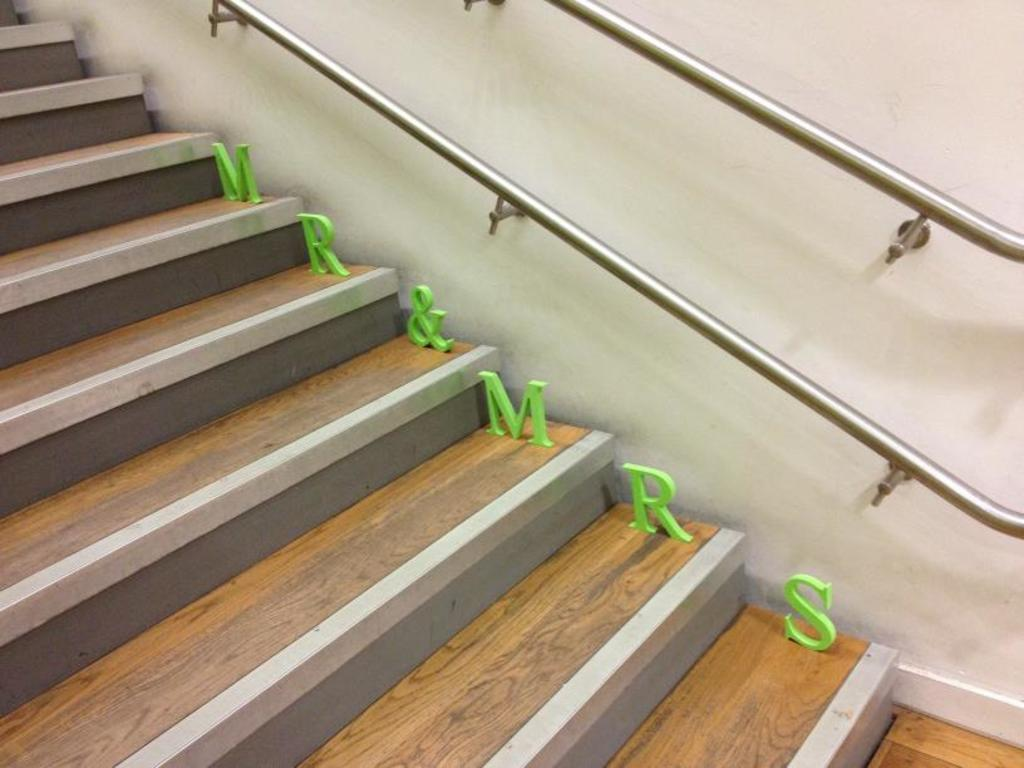What type of structure is present in the image? There is a staircase in the image. What can be seen on the staircase? Alphabets are visible in the image. What other objects are present in the image? There are rods in the image. What is visible in the background of the image? There is a wall in the background of the image. What date is marked on the calendar in the image? There is no calendar present in the image. Can you describe the door in the image? There is no door present in the image. 